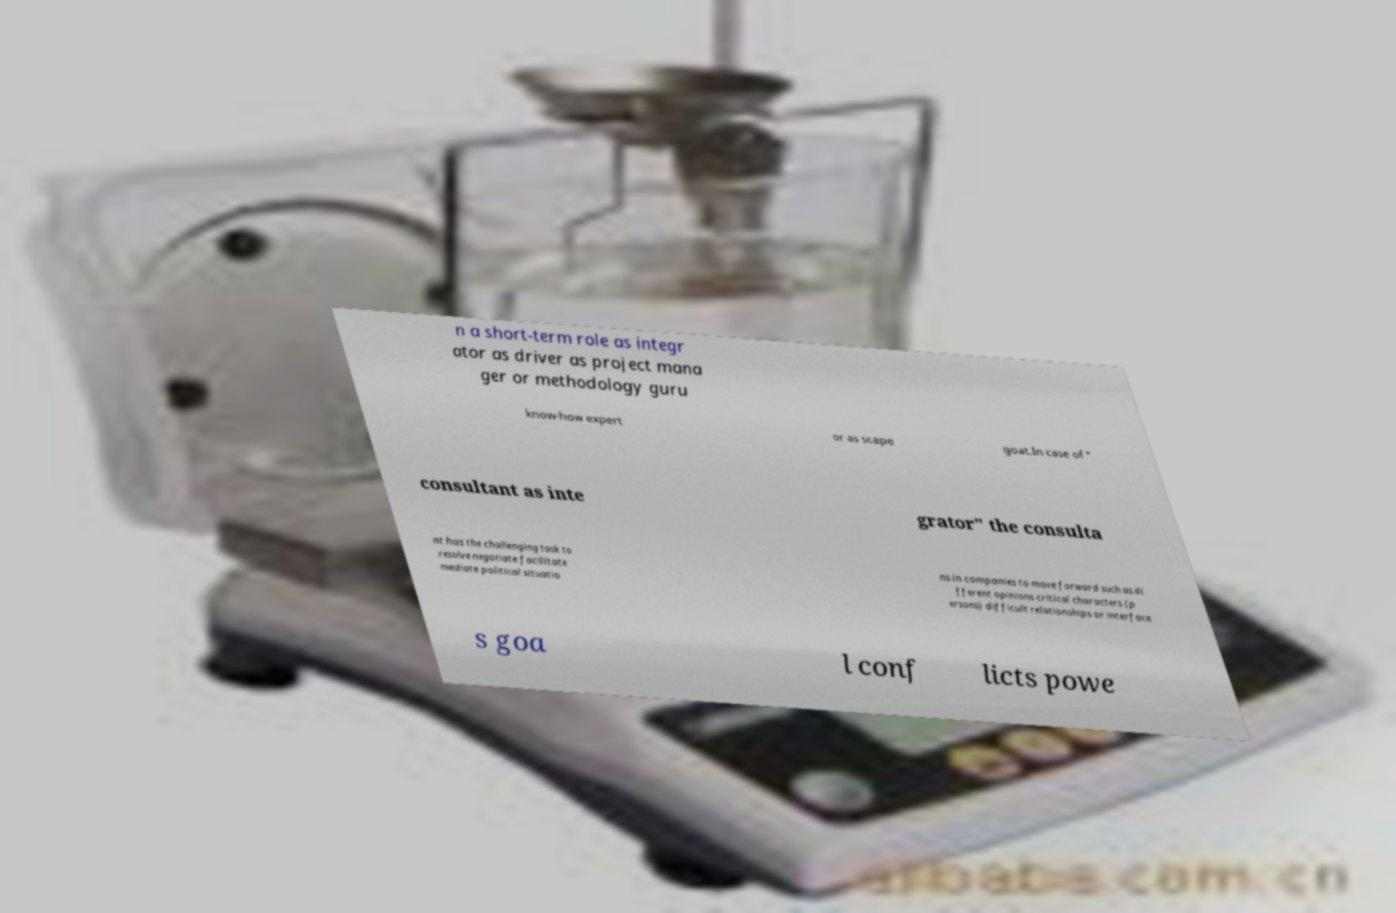Could you assist in decoding the text presented in this image and type it out clearly? n a short-term role as integr ator as driver as project mana ger or methodology guru know-how expert or as scape goat.In case of " consultant as inte grator" the consulta nt has the challenging task to resolve negotiate facilitate mediate political situatio ns in companies to move forward such as di fferent opinions critical characters (p ersons) difficult relationships or interface s goa l conf licts powe 